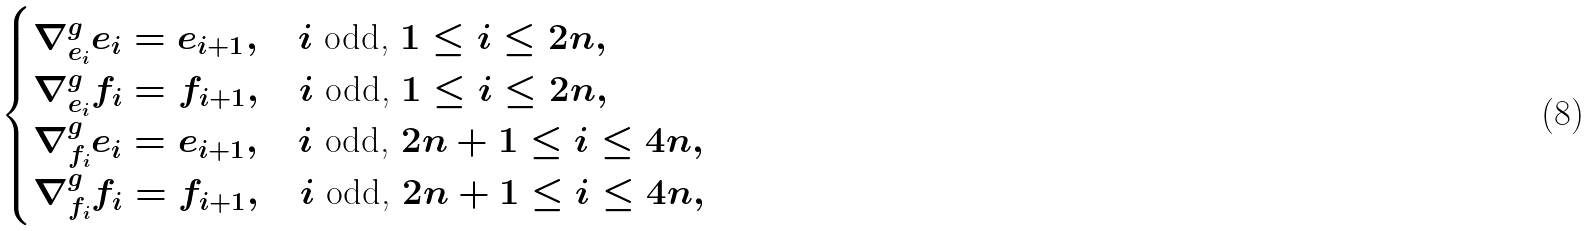Convert formula to latex. <formula><loc_0><loc_0><loc_500><loc_500>\begin{cases} \nabla ^ { g } _ { e _ { i } } e _ { i } = e _ { i + 1 } , \quad i \text { odd, } 1 \leq i \leq 2 n , \\ \nabla ^ { g } _ { e _ { i } } f _ { i } = f _ { i + 1 } , \quad i \text { odd, } 1 \leq i \leq 2 n , \\ \nabla ^ { g } _ { f _ { i } } e _ { i } = e _ { i + 1 } , \quad i \text { odd, } 2 n + 1 \leq i \leq 4 n , \\ \nabla ^ { g } _ { f _ { i } } f _ { i } = f _ { i + 1 } , \quad i \text { odd, } 2 n + 1 \leq i \leq 4 n , \end{cases}</formula> 